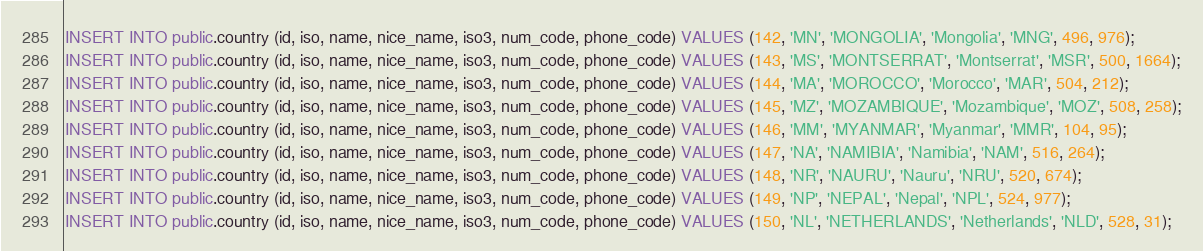Convert code to text. <code><loc_0><loc_0><loc_500><loc_500><_SQL_>INSERT INTO public.country (id, iso, name, nice_name, iso3, num_code, phone_code) VALUES (142, 'MN', 'MONGOLIA', 'Mongolia', 'MNG', 496, 976);
INSERT INTO public.country (id, iso, name, nice_name, iso3, num_code, phone_code) VALUES (143, 'MS', 'MONTSERRAT', 'Montserrat', 'MSR', 500, 1664);
INSERT INTO public.country (id, iso, name, nice_name, iso3, num_code, phone_code) VALUES (144, 'MA', 'MOROCCO', 'Morocco', 'MAR', 504, 212);
INSERT INTO public.country (id, iso, name, nice_name, iso3, num_code, phone_code) VALUES (145, 'MZ', 'MOZAMBIQUE', 'Mozambique', 'MOZ', 508, 258);
INSERT INTO public.country (id, iso, name, nice_name, iso3, num_code, phone_code) VALUES (146, 'MM', 'MYANMAR', 'Myanmar', 'MMR', 104, 95);
INSERT INTO public.country (id, iso, name, nice_name, iso3, num_code, phone_code) VALUES (147, 'NA', 'NAMIBIA', 'Namibia', 'NAM', 516, 264);
INSERT INTO public.country (id, iso, name, nice_name, iso3, num_code, phone_code) VALUES (148, 'NR', 'NAURU', 'Nauru', 'NRU', 520, 674);
INSERT INTO public.country (id, iso, name, nice_name, iso3, num_code, phone_code) VALUES (149, 'NP', 'NEPAL', 'Nepal', 'NPL', 524, 977);
INSERT INTO public.country (id, iso, name, nice_name, iso3, num_code, phone_code) VALUES (150, 'NL', 'NETHERLANDS', 'Netherlands', 'NLD', 528, 31);</code> 